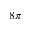Convert formula to latex. <formula><loc_0><loc_0><loc_500><loc_500>8 \pi</formula> 